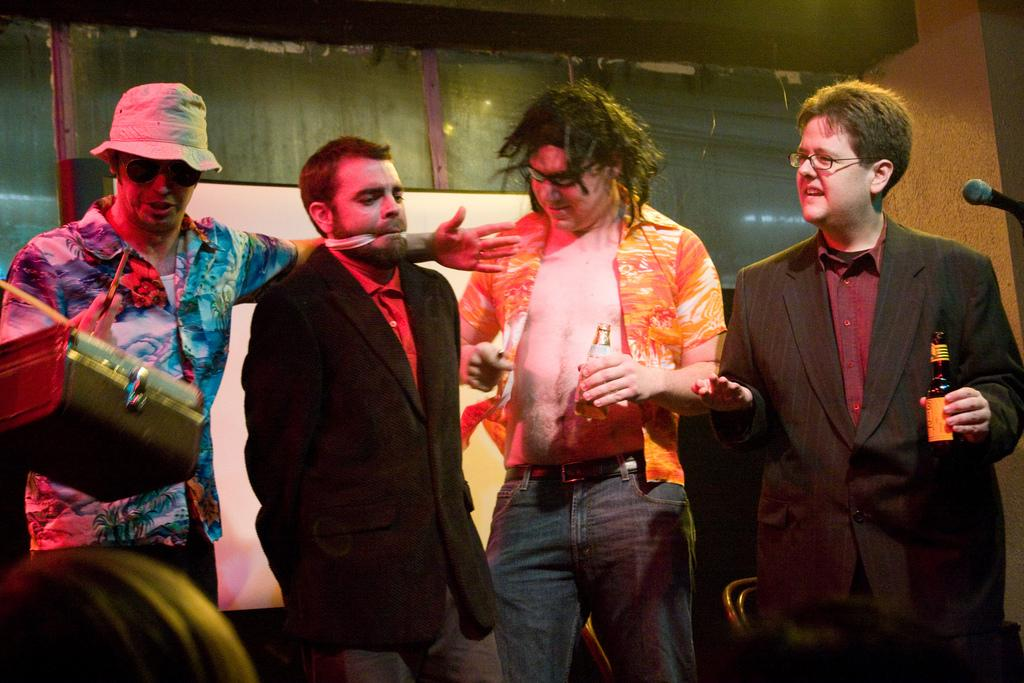How many people are in the image? There are four people in the image. What are two of the people holding? Two of the people are holding bottles. What type of furniture is present in the image? Chairs are present in the image. What object is used for amplifying sound in the image? There is a microphone (mic) in the image. Can you describe the headwear of one of the people in the image? At least one person is wearing a cap. What can be seen in the background of the image? There is a wall visible in the background of the image. How many dolls are sitting on the chairs in the image? There are no dolls present in the image; only people are visible. What type of hole can be seen in the wall in the image? There is no hole visible in the wall in the image. 